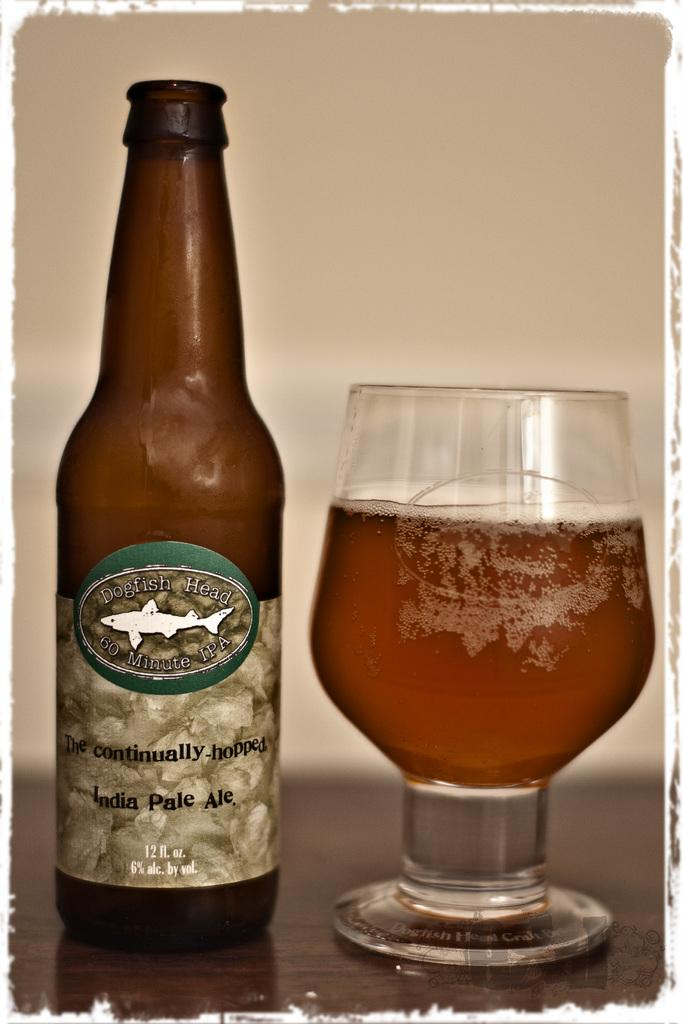<image>
Describe the image concisely. A bottle of Dogfish Head Ale sits on a table next to a glass 